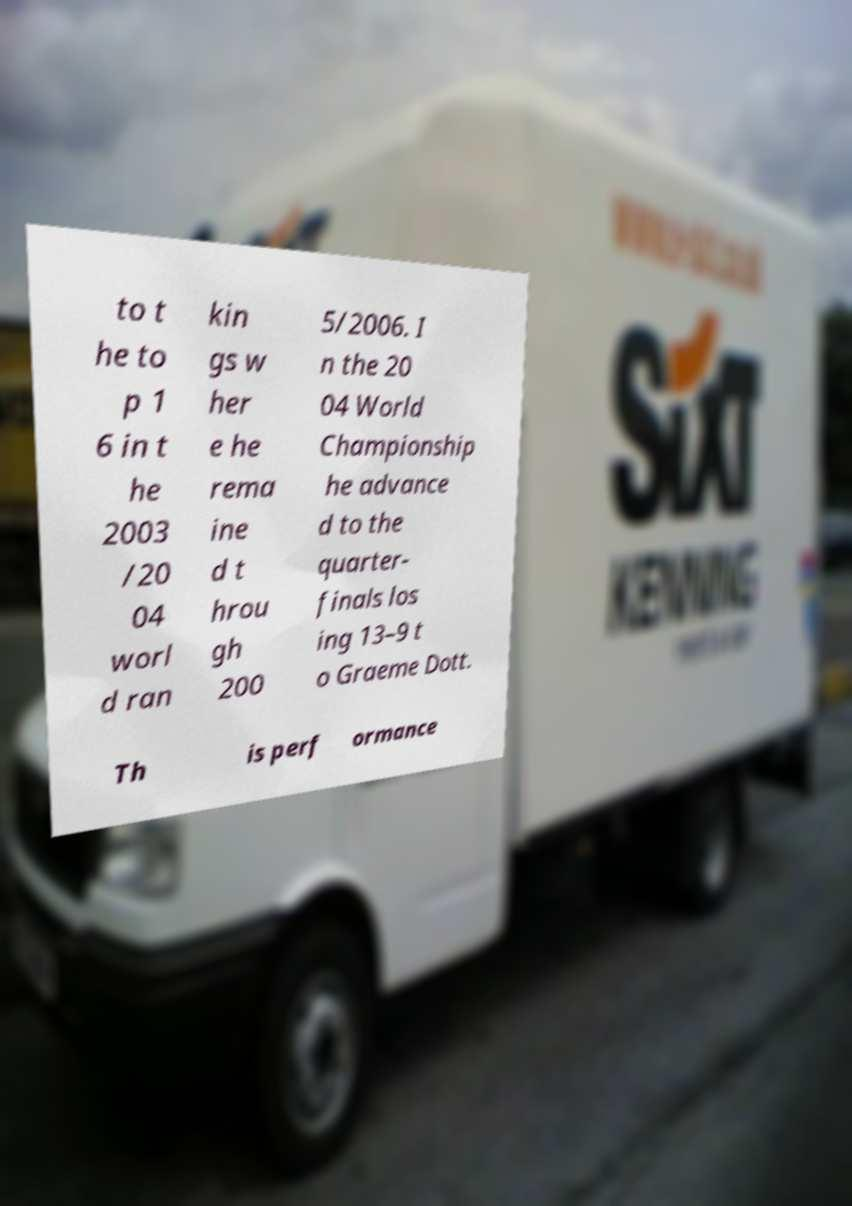Could you extract and type out the text from this image? to t he to p 1 6 in t he 2003 /20 04 worl d ran kin gs w her e he rema ine d t hrou gh 200 5/2006. I n the 20 04 World Championship he advance d to the quarter- finals los ing 13–9 t o Graeme Dott. Th is perf ormance 